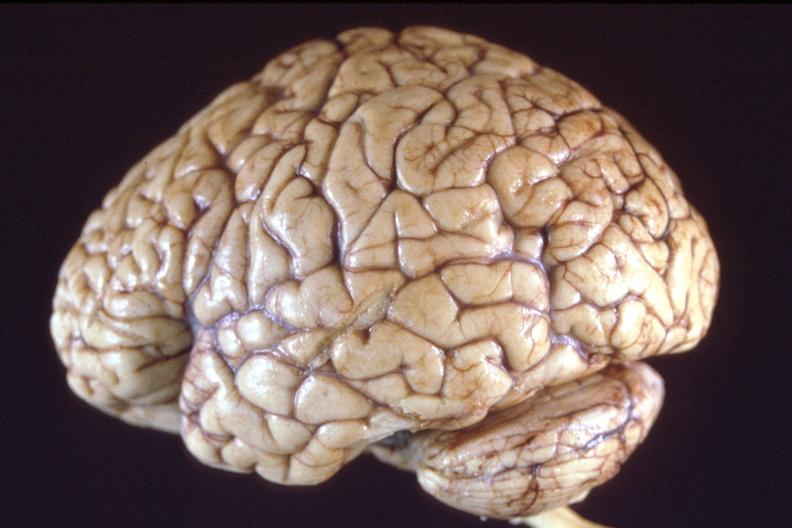what does this image show?
Answer the question using a single word or phrase. Brain 